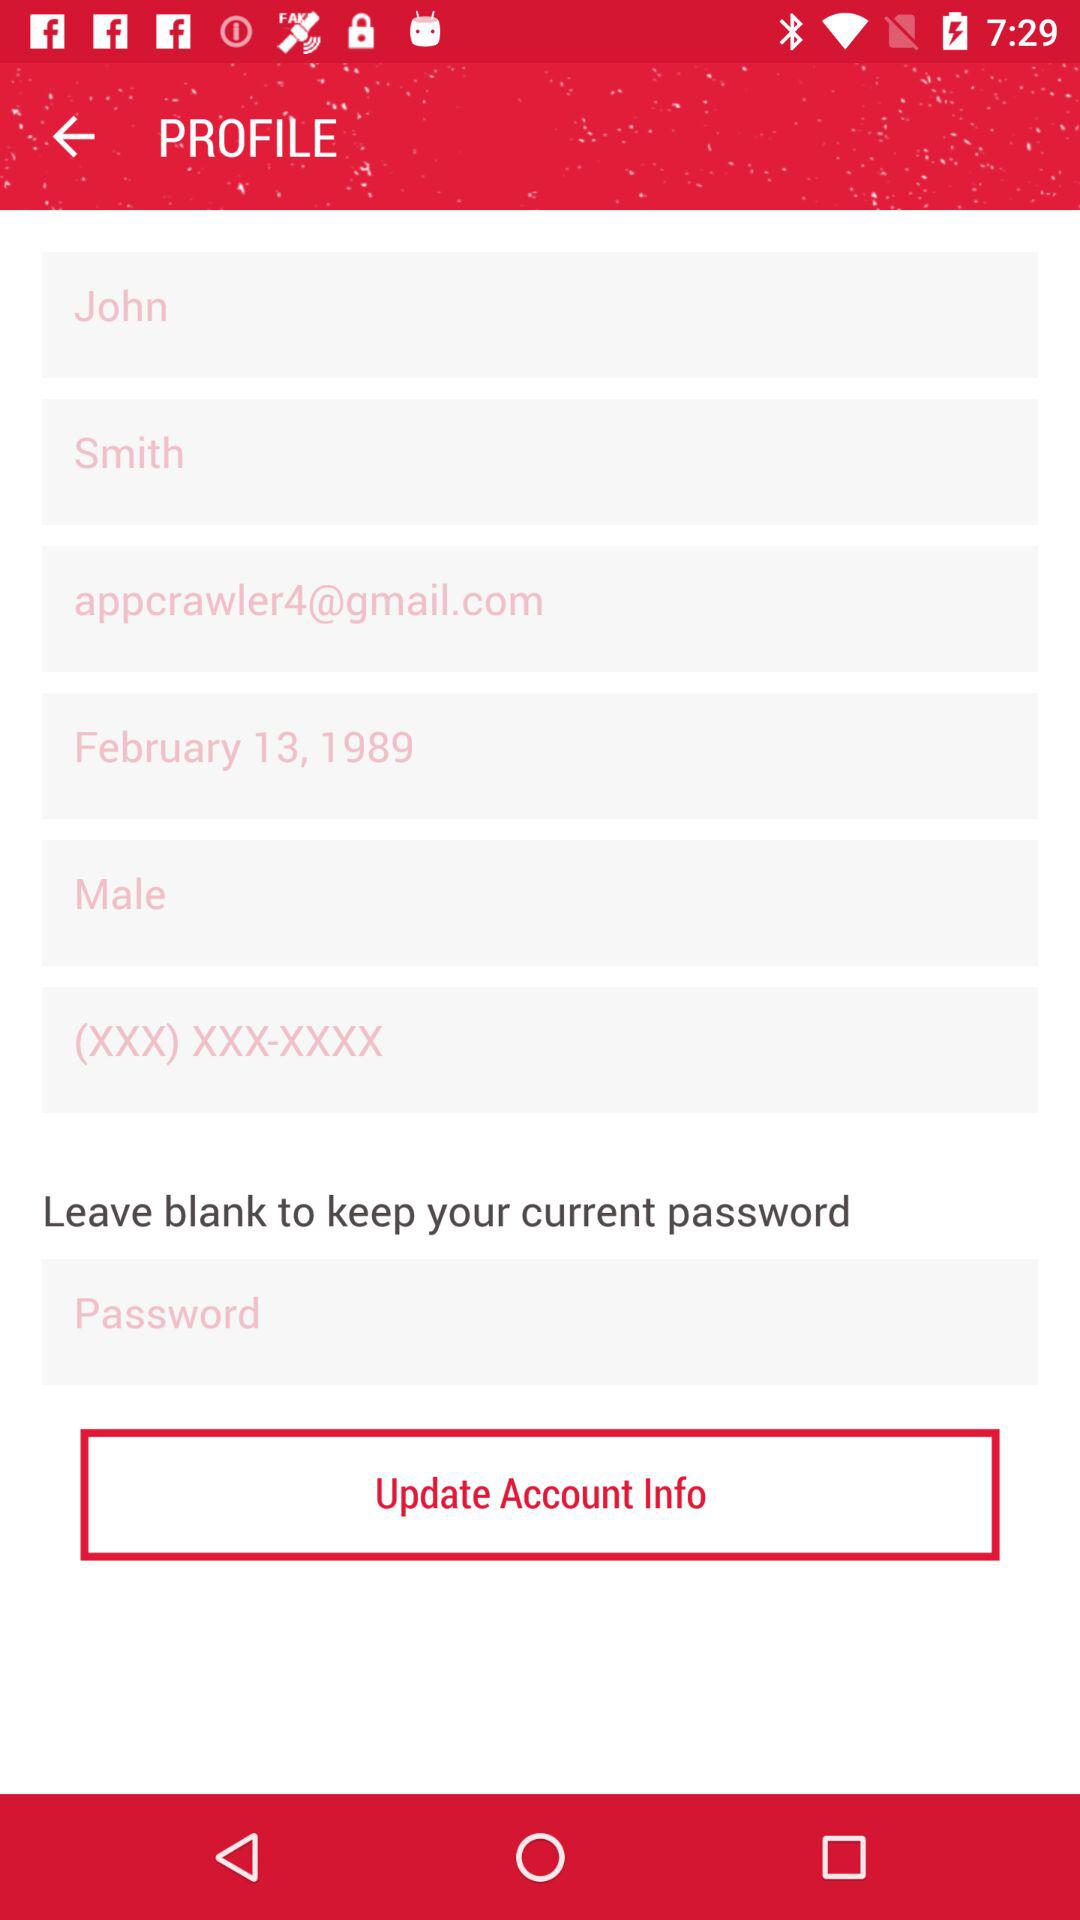What is the date of birth? The date of birth is February 13, 1989. 